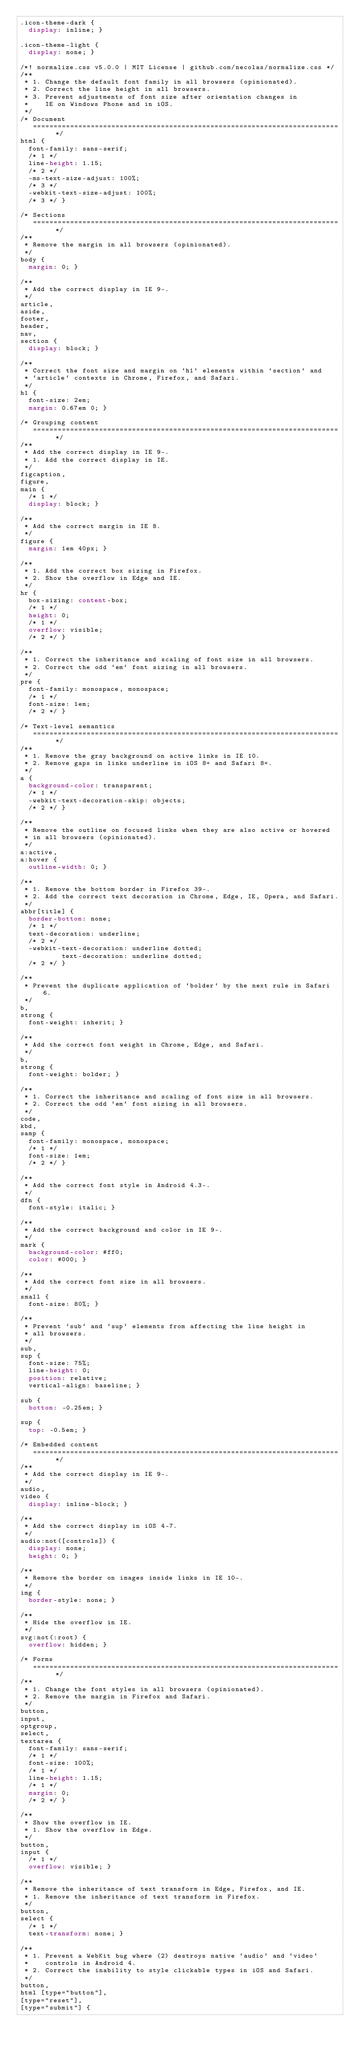Convert code to text. <code><loc_0><loc_0><loc_500><loc_500><_CSS_>.icon-theme-dark {
  display: inline; }

.icon-theme-light {
  display: none; }

/*! normalize.css v5.0.0 | MIT License | github.com/necolas/normalize.css */
/**
 * 1. Change the default font family in all browsers (opinionated).
 * 2. Correct the line height in all browsers.
 * 3. Prevent adjustments of font size after orientation changes in
 *    IE on Windows Phone and in iOS.
 */
/* Document
   ========================================================================== */
html {
  font-family: sans-serif;
  /* 1 */
  line-height: 1.15;
  /* 2 */
  -ms-text-size-adjust: 100%;
  /* 3 */
  -webkit-text-size-adjust: 100%;
  /* 3 */ }

/* Sections
   ========================================================================== */
/**
 * Remove the margin in all browsers (opinionated).
 */
body {
  margin: 0; }

/**
 * Add the correct display in IE 9-.
 */
article,
aside,
footer,
header,
nav,
section {
  display: block; }

/**
 * Correct the font size and margin on `h1` elements within `section` and
 * `article` contexts in Chrome, Firefox, and Safari.
 */
h1 {
  font-size: 2em;
  margin: 0.67em 0; }

/* Grouping content
   ========================================================================== */
/**
 * Add the correct display in IE 9-.
 * 1. Add the correct display in IE.
 */
figcaption,
figure,
main {
  /* 1 */
  display: block; }

/**
 * Add the correct margin in IE 8.
 */
figure {
  margin: 1em 40px; }

/**
 * 1. Add the correct box sizing in Firefox.
 * 2. Show the overflow in Edge and IE.
 */
hr {
  box-sizing: content-box;
  /* 1 */
  height: 0;
  /* 1 */
  overflow: visible;
  /* 2 */ }

/**
 * 1. Correct the inheritance and scaling of font size in all browsers.
 * 2. Correct the odd `em` font sizing in all browsers.
 */
pre {
  font-family: monospace, monospace;
  /* 1 */
  font-size: 1em;
  /* 2 */ }

/* Text-level semantics
   ========================================================================== */
/**
 * 1. Remove the gray background on active links in IE 10.
 * 2. Remove gaps in links underline in iOS 8+ and Safari 8+.
 */
a {
  background-color: transparent;
  /* 1 */
  -webkit-text-decoration-skip: objects;
  /* 2 */ }

/**
 * Remove the outline on focused links when they are also active or hovered
 * in all browsers (opinionated).
 */
a:active,
a:hover {
  outline-width: 0; }

/**
 * 1. Remove the bottom border in Firefox 39-.
 * 2. Add the correct text decoration in Chrome, Edge, IE, Opera, and Safari.
 */
abbr[title] {
  border-bottom: none;
  /* 1 */
  text-decoration: underline;
  /* 2 */
  -webkit-text-decoration: underline dotted;
          text-decoration: underline dotted;
  /* 2 */ }

/**
 * Prevent the duplicate application of `bolder` by the next rule in Safari 6.
 */
b,
strong {
  font-weight: inherit; }

/**
 * Add the correct font weight in Chrome, Edge, and Safari.
 */
b,
strong {
  font-weight: bolder; }

/**
 * 1. Correct the inheritance and scaling of font size in all browsers.
 * 2. Correct the odd `em` font sizing in all browsers.
 */
code,
kbd,
samp {
  font-family: monospace, monospace;
  /* 1 */
  font-size: 1em;
  /* 2 */ }

/**
 * Add the correct font style in Android 4.3-.
 */
dfn {
  font-style: italic; }

/**
 * Add the correct background and color in IE 9-.
 */
mark {
  background-color: #ff0;
  color: #000; }

/**
 * Add the correct font size in all browsers.
 */
small {
  font-size: 80%; }

/**
 * Prevent `sub` and `sup` elements from affecting the line height in
 * all browsers.
 */
sub,
sup {
  font-size: 75%;
  line-height: 0;
  position: relative;
  vertical-align: baseline; }

sub {
  bottom: -0.25em; }

sup {
  top: -0.5em; }

/* Embedded content
   ========================================================================== */
/**
 * Add the correct display in IE 9-.
 */
audio,
video {
  display: inline-block; }

/**
 * Add the correct display in iOS 4-7.
 */
audio:not([controls]) {
  display: none;
  height: 0; }

/**
 * Remove the border on images inside links in IE 10-.
 */
img {
  border-style: none; }

/**
 * Hide the overflow in IE.
 */
svg:not(:root) {
  overflow: hidden; }

/* Forms
   ========================================================================== */
/**
 * 1. Change the font styles in all browsers (opinionated).
 * 2. Remove the margin in Firefox and Safari.
 */
button,
input,
optgroup,
select,
textarea {
  font-family: sans-serif;
  /* 1 */
  font-size: 100%;
  /* 1 */
  line-height: 1.15;
  /* 1 */
  margin: 0;
  /* 2 */ }

/**
 * Show the overflow in IE.
 * 1. Show the overflow in Edge.
 */
button,
input {
  /* 1 */
  overflow: visible; }

/**
 * Remove the inheritance of text transform in Edge, Firefox, and IE.
 * 1. Remove the inheritance of text transform in Firefox.
 */
button,
select {
  /* 1 */
  text-transform: none; }

/**
 * 1. Prevent a WebKit bug where (2) destroys native `audio` and `video`
 *    controls in Android 4.
 * 2. Correct the inability to style clickable types in iOS and Safari.
 */
button,
html [type="button"],
[type="reset"],
[type="submit"] {</code> 